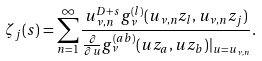<formula> <loc_0><loc_0><loc_500><loc_500>\zeta _ { j } ( s ) = \sum _ { n = 1 } ^ { \infty } \frac { u _ { \nu , n } ^ { D + s } g _ { \nu } ^ { ( l ) } ( u _ { \nu , n } z _ { l } , u _ { \nu , n } z _ { j } ) } { \frac { \partial } { \partial u } g _ { \nu } ^ { ( a b ) } ( u z _ { a } , u z _ { b } ) | _ { u = u _ { \nu , n } } } .</formula> 